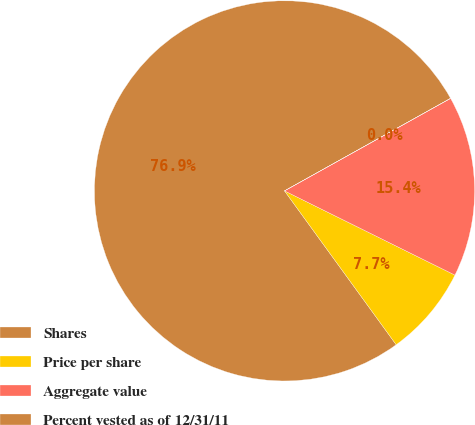Convert chart. <chart><loc_0><loc_0><loc_500><loc_500><pie_chart><fcel>Shares<fcel>Price per share<fcel>Aggregate value<fcel>Percent vested as of 12/31/11<nl><fcel>76.89%<fcel>7.7%<fcel>15.39%<fcel>0.01%<nl></chart> 